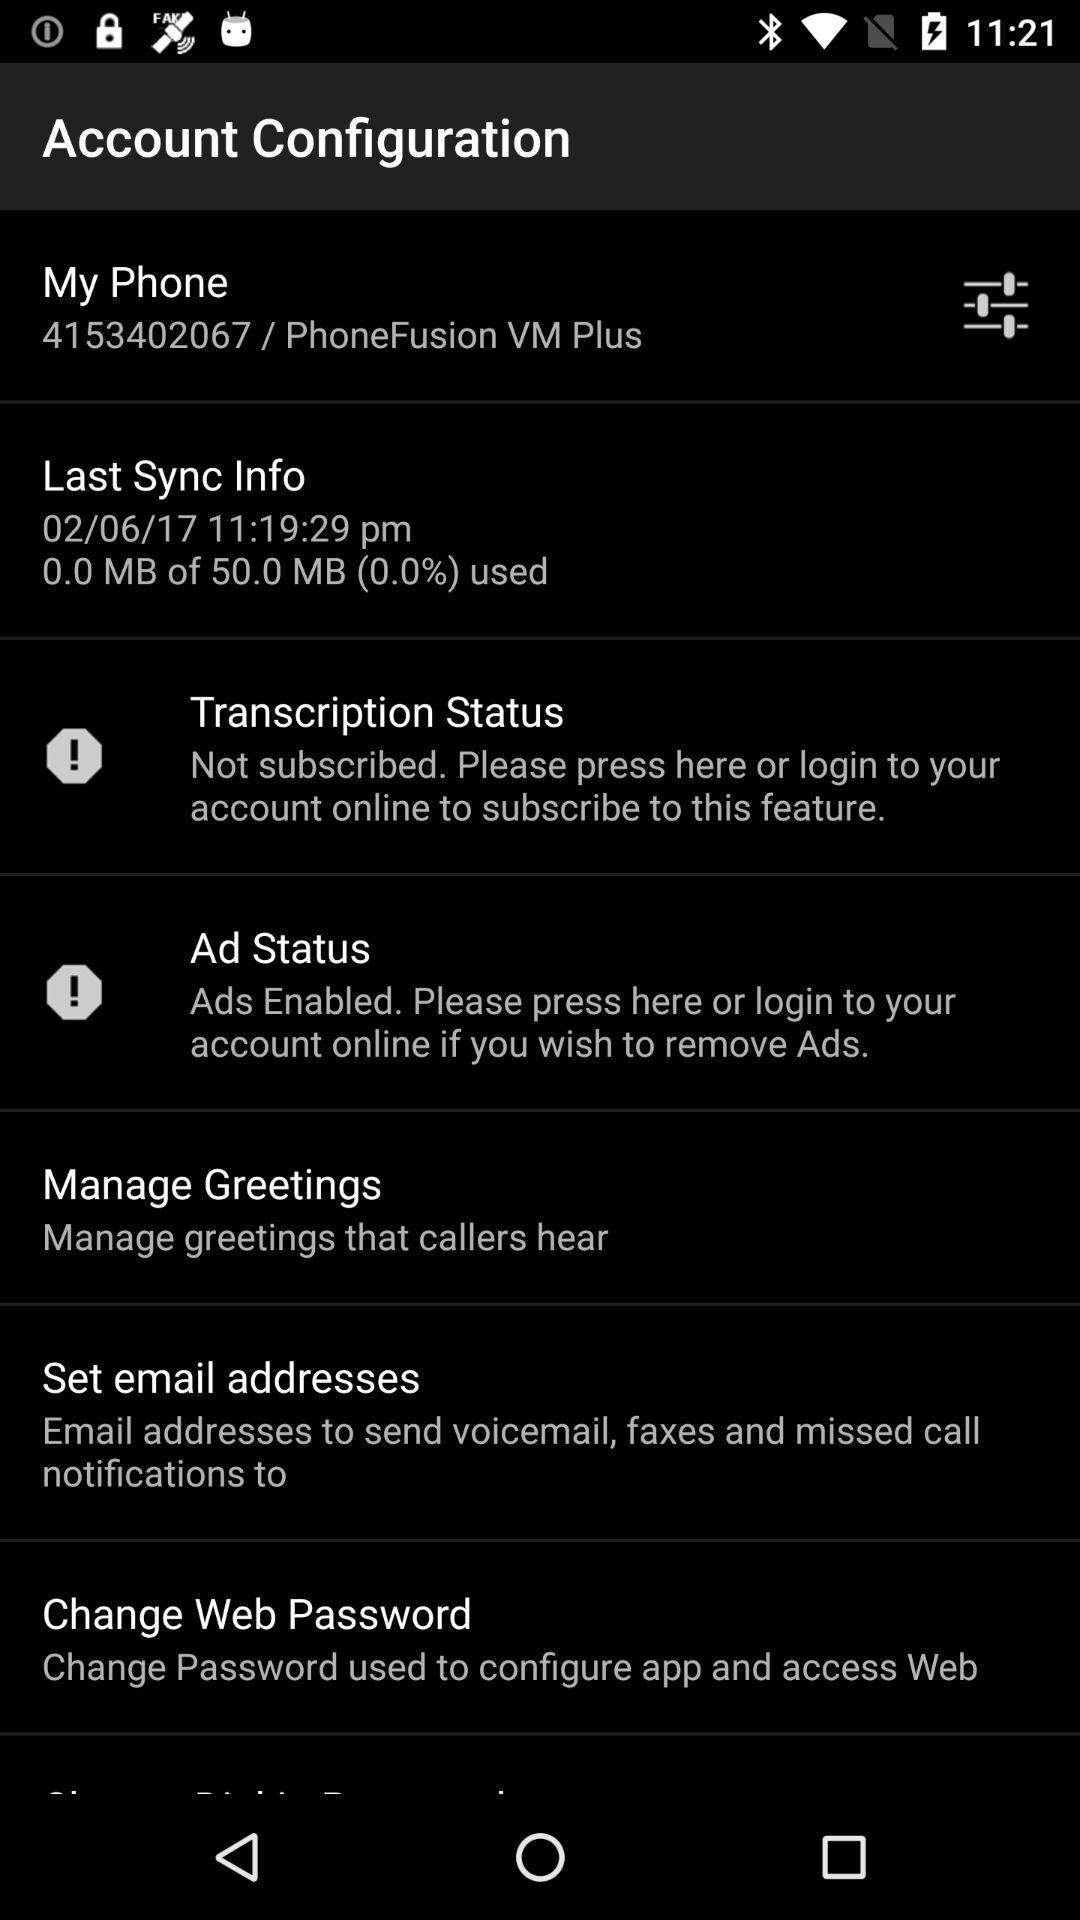How many MB have been used? The used MB is 0.0. 